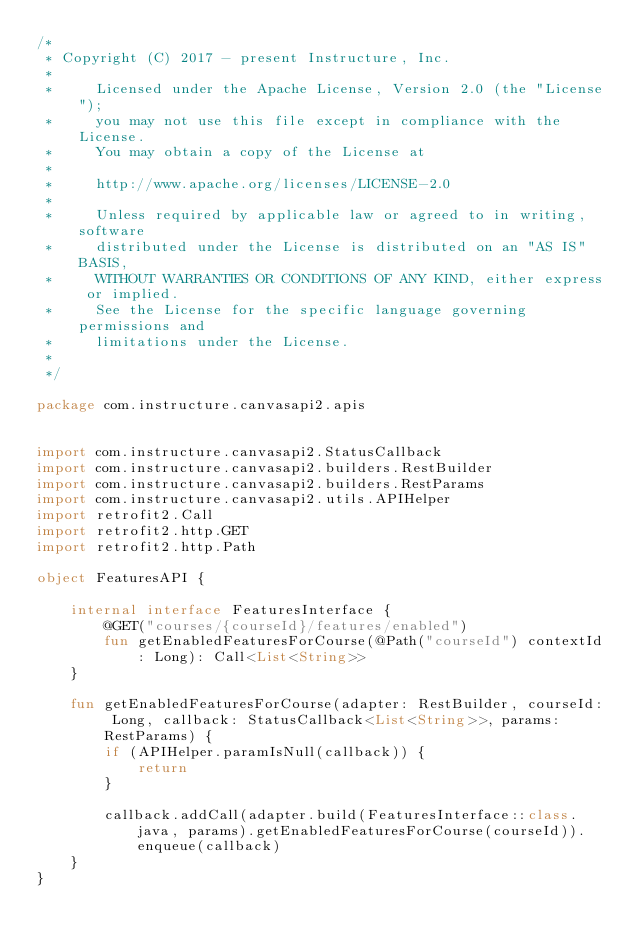<code> <loc_0><loc_0><loc_500><loc_500><_Kotlin_>/*
 * Copyright (C) 2017 - present Instructure, Inc.
 *
 *     Licensed under the Apache License, Version 2.0 (the "License");
 *     you may not use this file except in compliance with the License.
 *     You may obtain a copy of the License at
 *
 *     http://www.apache.org/licenses/LICENSE-2.0
 *
 *     Unless required by applicable law or agreed to in writing, software
 *     distributed under the License is distributed on an "AS IS" BASIS,
 *     WITHOUT WARRANTIES OR CONDITIONS OF ANY KIND, either express or implied.
 *     See the License for the specific language governing permissions and
 *     limitations under the License.
 *
 */

package com.instructure.canvasapi2.apis


import com.instructure.canvasapi2.StatusCallback
import com.instructure.canvasapi2.builders.RestBuilder
import com.instructure.canvasapi2.builders.RestParams
import com.instructure.canvasapi2.utils.APIHelper
import retrofit2.Call
import retrofit2.http.GET
import retrofit2.http.Path

object FeaturesAPI {

    internal interface FeaturesInterface {
        @GET("courses/{courseId}/features/enabled")
        fun getEnabledFeaturesForCourse(@Path("courseId") contextId: Long): Call<List<String>>
    }

    fun getEnabledFeaturesForCourse(adapter: RestBuilder, courseId: Long, callback: StatusCallback<List<String>>, params: RestParams) {
        if (APIHelper.paramIsNull(callback)) {
            return
        }

        callback.addCall(adapter.build(FeaturesInterface::class.java, params).getEnabledFeaturesForCourse(courseId)).enqueue(callback)
    }
}
</code> 